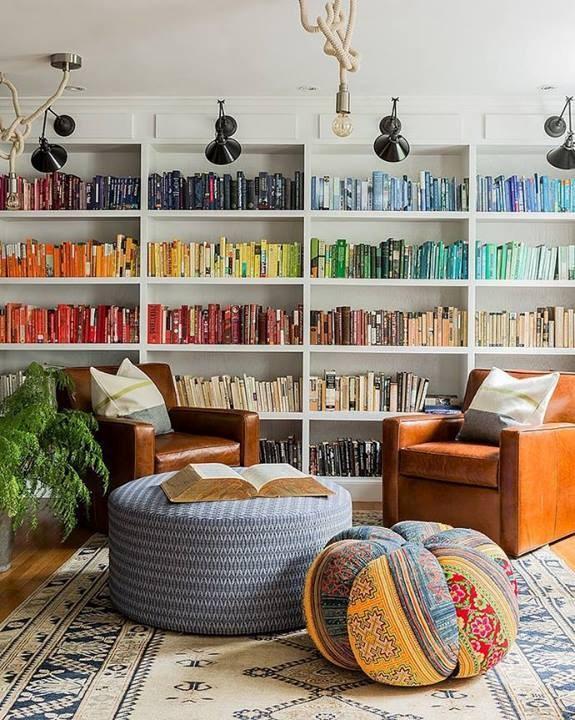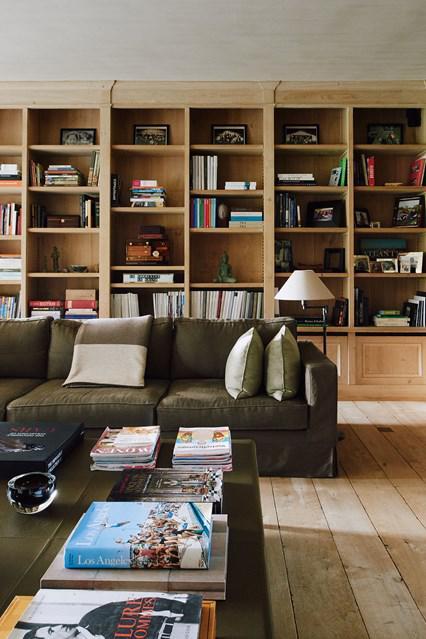The first image is the image on the left, the second image is the image on the right. Evaluate the accuracy of this statement regarding the images: "The white bookshelves in one image are floor to ceiling, while those in the second image stop short of the ceiling and have decorative items displayed on top.". Is it true? Answer yes or no. No. 